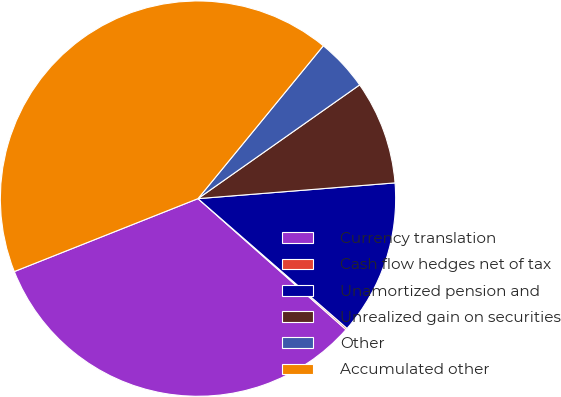<chart> <loc_0><loc_0><loc_500><loc_500><pie_chart><fcel>Currency translation<fcel>Cash flow hedges net of tax<fcel>Unamortized pension and<fcel>Unrealized gain on securities<fcel>Other<fcel>Accumulated other<nl><fcel>32.45%<fcel>0.13%<fcel>12.67%<fcel>8.49%<fcel>4.31%<fcel>41.94%<nl></chart> 